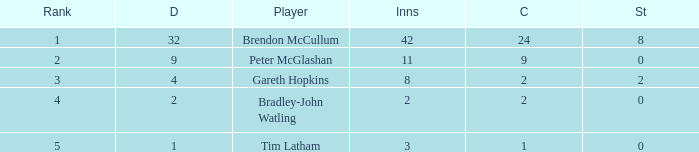Enumerate the positions of all 4-point dismissals. 3.0. 